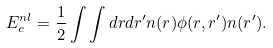<formula> <loc_0><loc_0><loc_500><loc_500>E _ { c } ^ { n l } = \frac { 1 } { 2 } \int \int d r d r ^ { \prime } n ( r ) \phi ( r , r ^ { \prime } ) n ( r ^ { \prime } ) .</formula> 